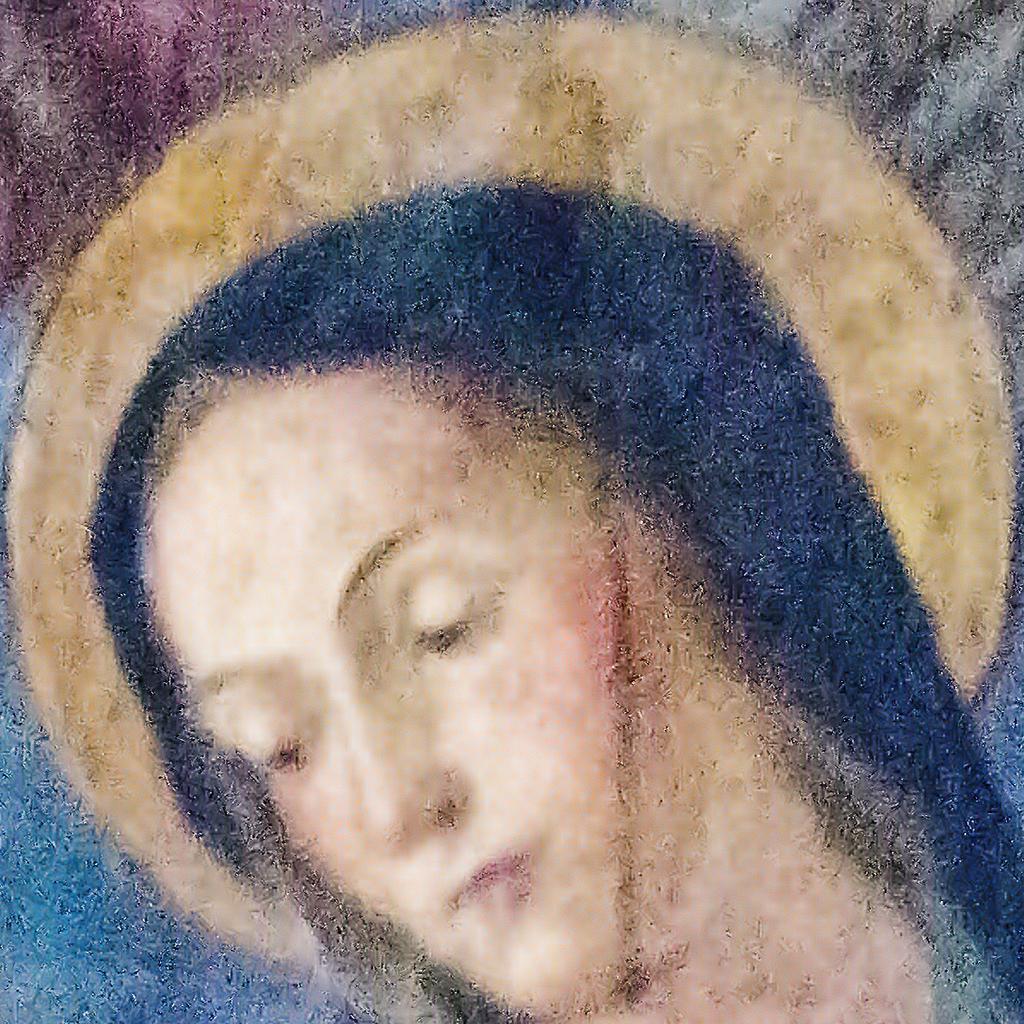How would you summarize this image in a sentence or two? This is a painting. In this painting we can see there is a woman. In the background, there is a moon. 